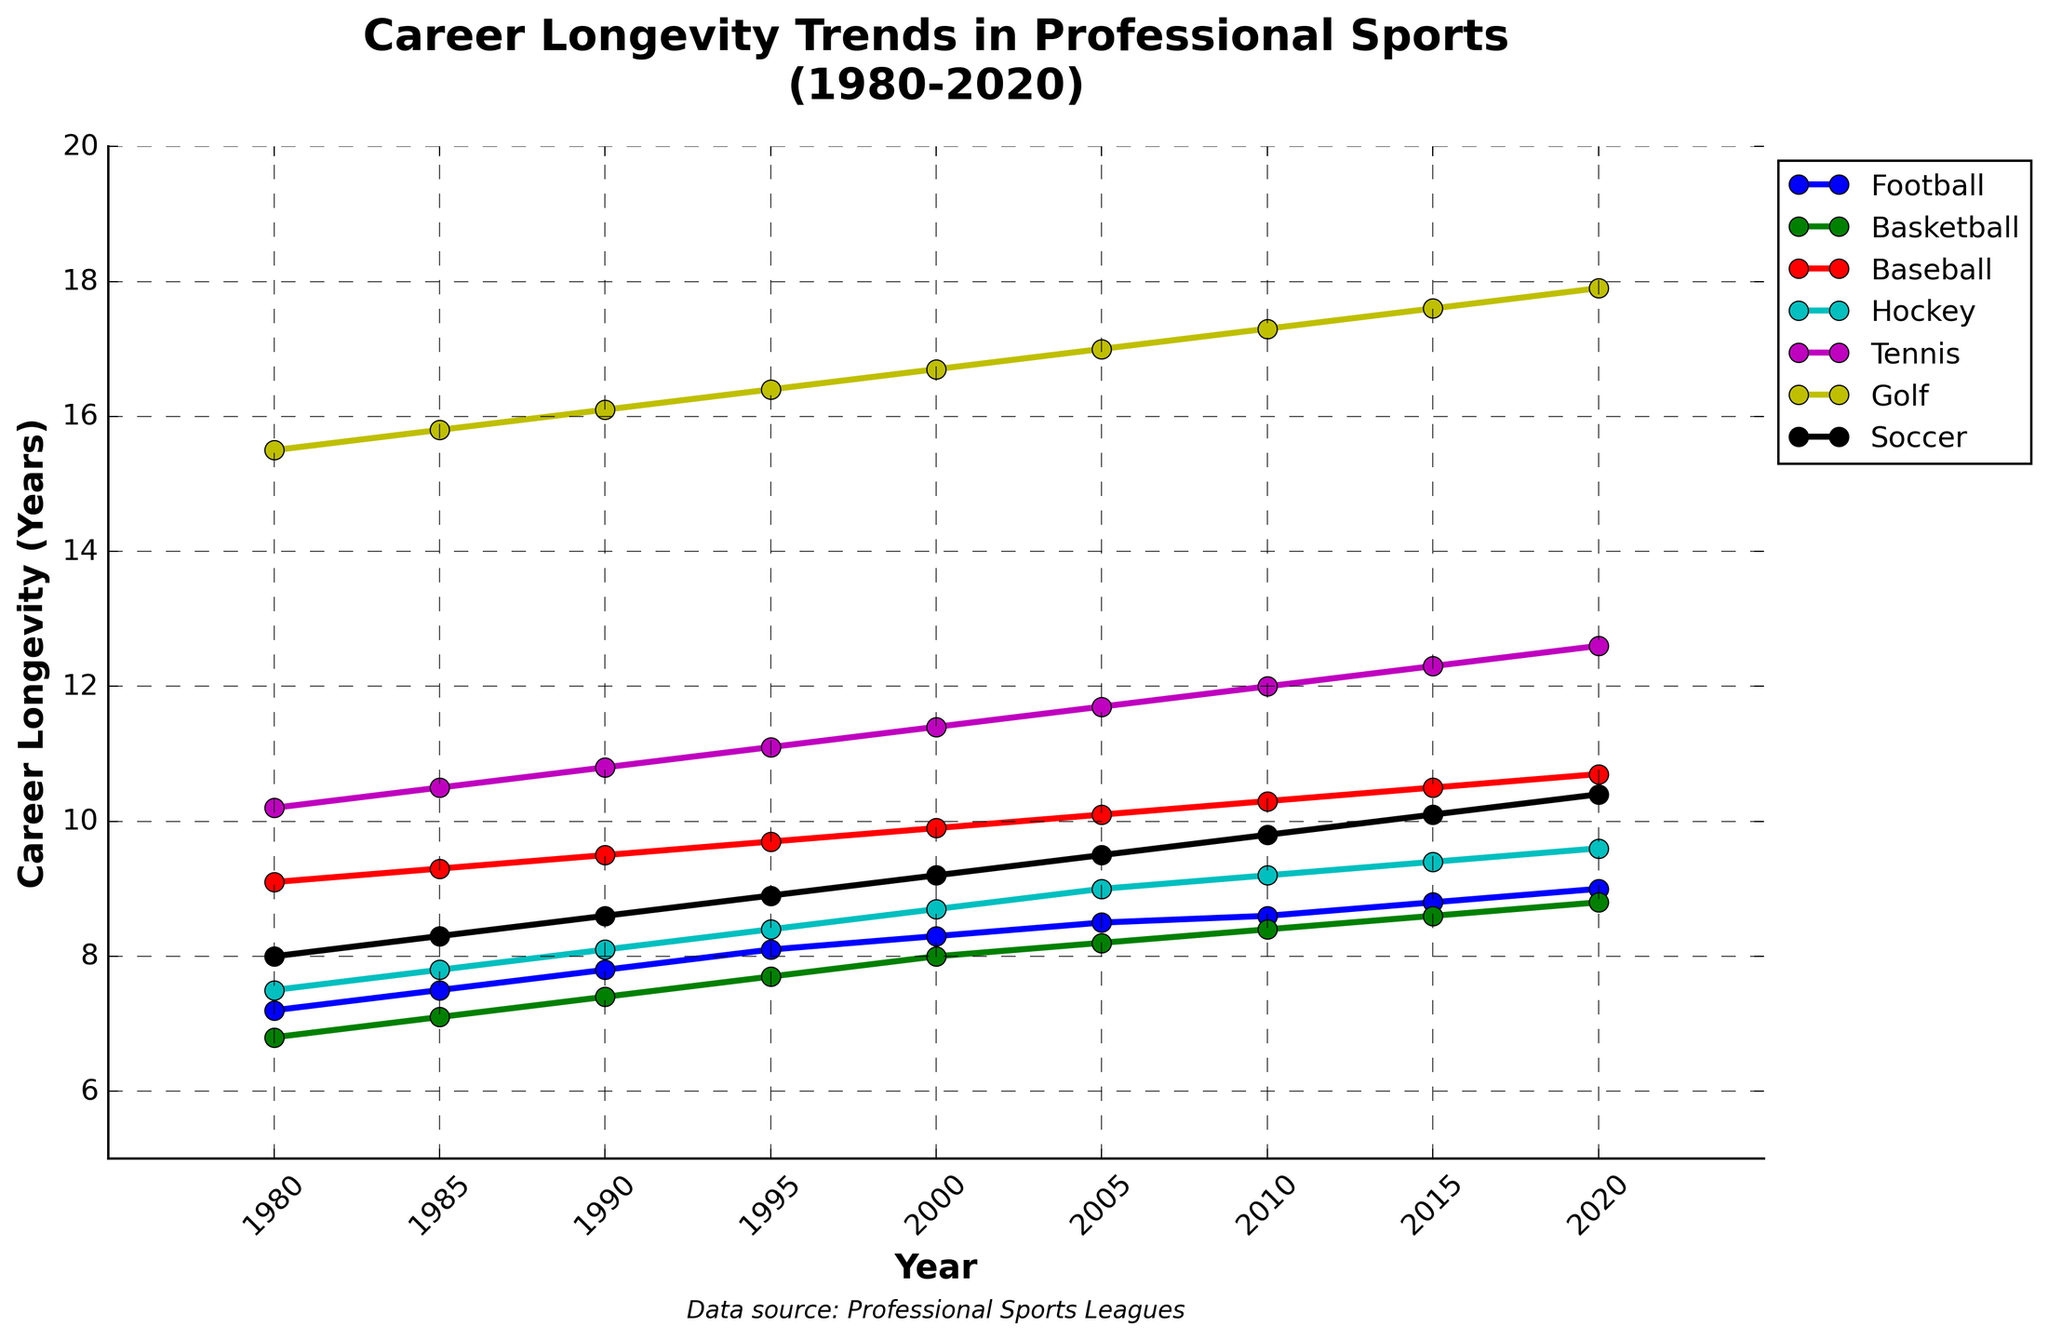Which sport had the greatest increase in career longevity between 1980 and 2020? Compare the longevity values in 1980 and 2020 for each sport. Football increased by 1.8 years (9.0 - 7.2), Basketball by 2.0 years (8.8 - 6.8), Baseball by 1.6 years (10.7 - 9.1), Hockey by 2.1 years (9.6 - 7.5), Tennis by 2.4 years (12.6 - 10.2), Golf by 2.4 years (17.9 - 15.5), and Soccer by 2.4 years (10.4 - 8.0). Golf, Tennis, and Soccer had the highest increase, each with 2.4 years.
Answer: Golf, Tennis, Soccer Which sport shows the longest average career longevity over the entire period? Calculate the average of career longevity values for each sport from 1980 to 2020. Golf had longevity values (15.5, 15.8, 16.1, 16.4, 16.7, 17.0, 17.3, 17.6, 17.9) which average to 16.7 years, the longest among the listed sports.
Answer: Golf By how many years did the career longevity of Tennis players increase from 1990 to 2020? Subtract the longevity value of Tennis in 1990 from that in 2020. The longevity in 1990 was 10.8 years, and in 2020 it was 12.6 years, resulting in an increase of 1.8 years.
Answer: 1.8 years What is the difference in career longevity between Basketball and Soccer in 2020? Subtract the longevity value of Soccer in 2020 from that of Basketball. Basketball's longevity in 2020 is 8.8 years; Soccer's is 10.4 years. The difference is 10.4 - 8.8 = 1.6 years.
Answer: 1.6 years Which sport experienced the smallest increase in career longevity from 1980 to 2020? Compare the increase in each sport by subtracting the 1980 value from the 2020 value. Football increased by 1.8 years, Basketball by 2.0 years, Baseball by 1.6 years, Hockey by 2.1 years, Tennis by 2.4 years, Golf by 2.4 years, and Soccer by 2.4 years. Baseball had the smallest increase of 1.6 years.
Answer: Baseball What year did Hockey players' career longevity surpass the 8-year mark? Identify the year when Hockey's career longevity surpasses 8 years. From the data, Hockey surpassed 8 years in 1990 with a value of 8.1 years.
Answer: 1990 Between Football and Hockey, which sport had a greater absolute increase in career longevity from 1980 to 2000? Calculate the change for both sports from 1980 to 2000. Football increased from 7.2 years in 1980 to 8.3 years in 2000, an increase of 1.1 years. Hockey increased from 7.5 years in 1980 to 8.7 years in 2000, an increase of 1.2 years. Hockey had a greater increase.
Answer: Hockey By how many years did Baseball players' career longevity change from 1985 to 2015? Subtract the longevity value of Baseball in 1985 from 2015. The longevity in 1985 was 9.3 years, and in 2015 it was 10.5 years, resulting in a change of 10.5 - 9.3 = 1.2 years.
Answer: 1.2 years Which sport had the second highest career longevity in 2005? List the career longevity values for each sport in 2005 and rank them. In 2005, Golf was the highest with 17 years, Tennis had 11.7 years being the second highest.
Answer: Tennis 